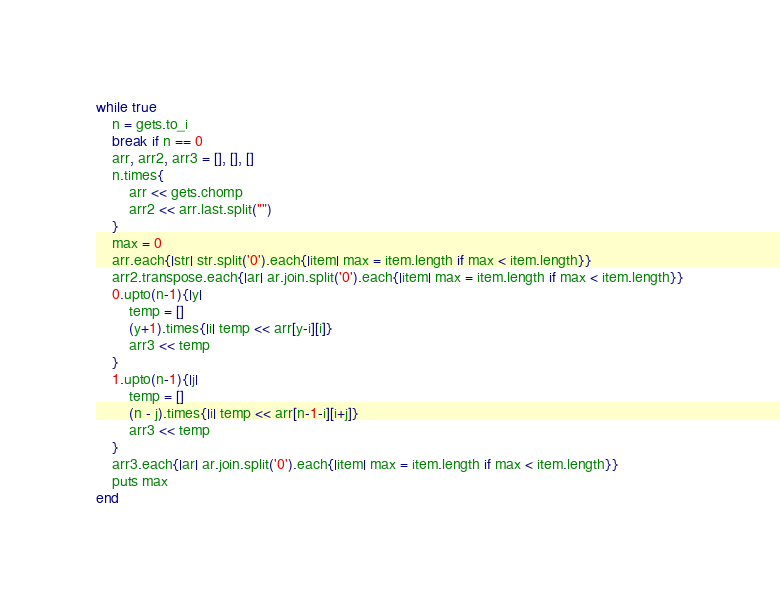Convert code to text. <code><loc_0><loc_0><loc_500><loc_500><_Ruby_>while true
    n = gets.to_i
    break if n == 0
    arr, arr2, arr3 = [], [], []
    n.times{
        arr << gets.chomp
        arr2 << arr.last.split("")
    }
    max = 0
    arr.each{|str| str.split('0').each{|item| max = item.length if max < item.length}}
    arr2.transpose.each{|ar| ar.join.split('0').each{|item| max = item.length if max < item.length}}
    0.upto(n-1){|y|
        temp = []
        (y+1).times{|i| temp << arr[y-i][i]}
        arr3 << temp
    }
    1.upto(n-1){|j|
        temp = []
        (n - j).times{|i| temp << arr[n-1-i][i+j]}
        arr3 << temp
    }
    arr3.each{|ar| ar.join.split('0').each{|item| max = item.length if max < item.length}}
    puts max
end
</code> 